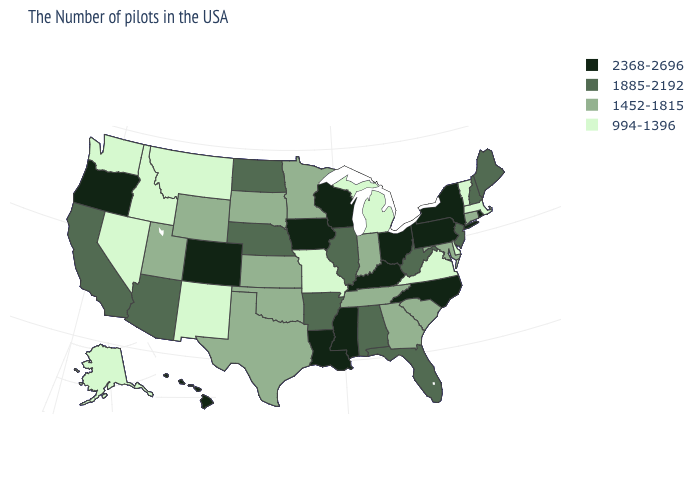What is the value of West Virginia?
Be succinct. 1885-2192. What is the value of Connecticut?
Give a very brief answer. 1452-1815. Name the states that have a value in the range 1452-1815?
Concise answer only. Connecticut, Maryland, South Carolina, Georgia, Indiana, Tennessee, Minnesota, Kansas, Oklahoma, Texas, South Dakota, Wyoming, Utah. What is the value of New Mexico?
Short answer required. 994-1396. Name the states that have a value in the range 2368-2696?
Be succinct. Rhode Island, New York, Pennsylvania, North Carolina, Ohio, Kentucky, Wisconsin, Mississippi, Louisiana, Iowa, Colorado, Oregon, Hawaii. What is the lowest value in states that border Nebraska?
Keep it brief. 994-1396. Does the map have missing data?
Be succinct. No. What is the highest value in the MidWest ?
Write a very short answer. 2368-2696. Does the first symbol in the legend represent the smallest category?
Be succinct. No. Among the states that border New Mexico , does Utah have the highest value?
Write a very short answer. No. Which states hav the highest value in the West?
Concise answer only. Colorado, Oregon, Hawaii. What is the value of Idaho?
Give a very brief answer. 994-1396. What is the lowest value in the USA?
Answer briefly. 994-1396. What is the value of Wisconsin?
Concise answer only. 2368-2696. What is the highest value in states that border Iowa?
Write a very short answer. 2368-2696. 